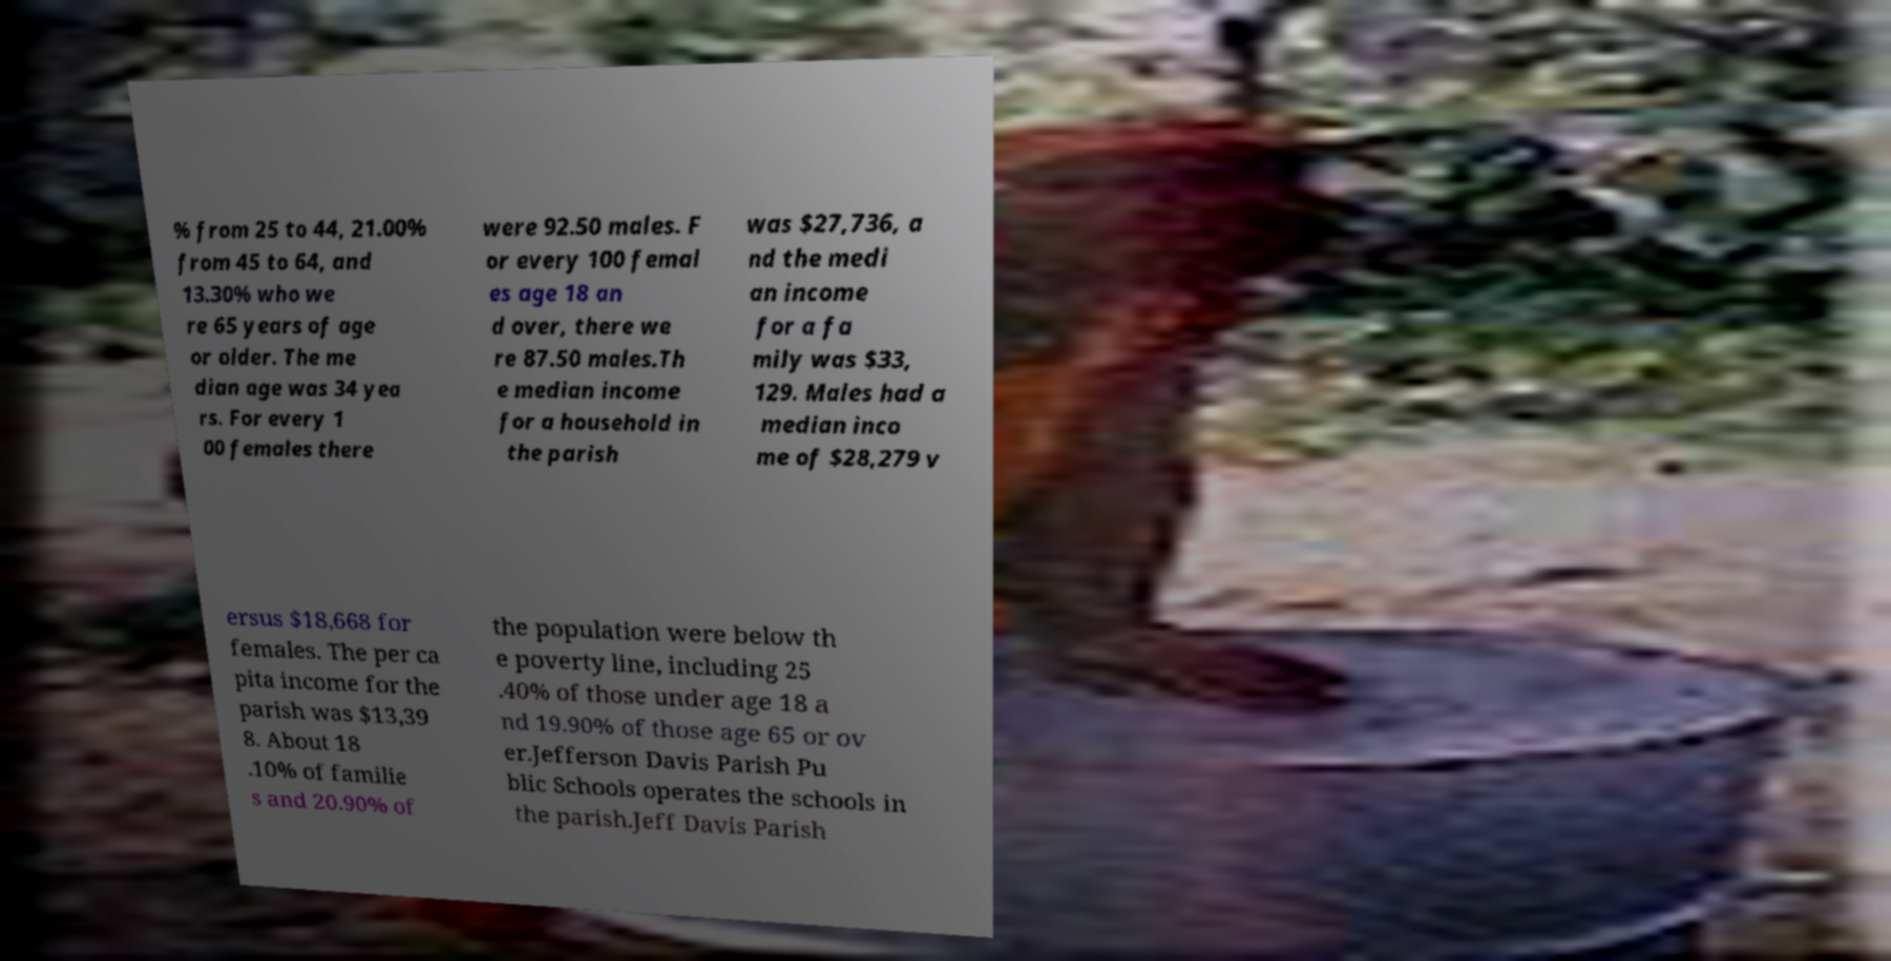Please identify and transcribe the text found in this image. % from 25 to 44, 21.00% from 45 to 64, and 13.30% who we re 65 years of age or older. The me dian age was 34 yea rs. For every 1 00 females there were 92.50 males. F or every 100 femal es age 18 an d over, there we re 87.50 males.Th e median income for a household in the parish was $27,736, a nd the medi an income for a fa mily was $33, 129. Males had a median inco me of $28,279 v ersus $18,668 for females. The per ca pita income for the parish was $13,39 8. About 18 .10% of familie s and 20.90% of the population were below th e poverty line, including 25 .40% of those under age 18 a nd 19.90% of those age 65 or ov er.Jefferson Davis Parish Pu blic Schools operates the schools in the parish.Jeff Davis Parish 